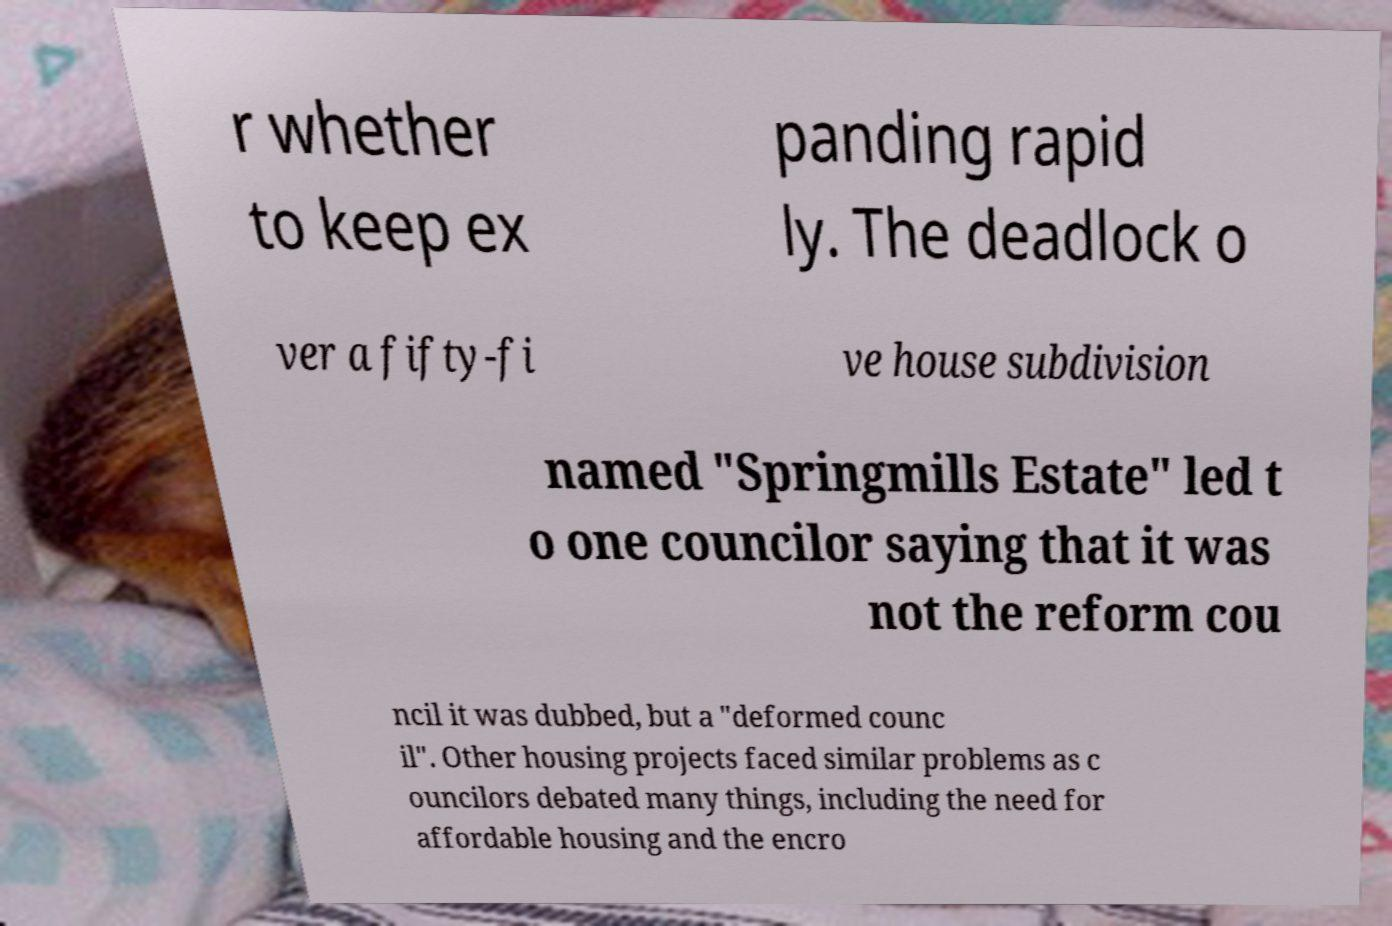Please read and relay the text visible in this image. What does it say? r whether to keep ex panding rapid ly. The deadlock o ver a fifty-fi ve house subdivision named "Springmills Estate" led t o one councilor saying that it was not the reform cou ncil it was dubbed, but a "deformed counc il". Other housing projects faced similar problems as c ouncilors debated many things, including the need for affordable housing and the encro 